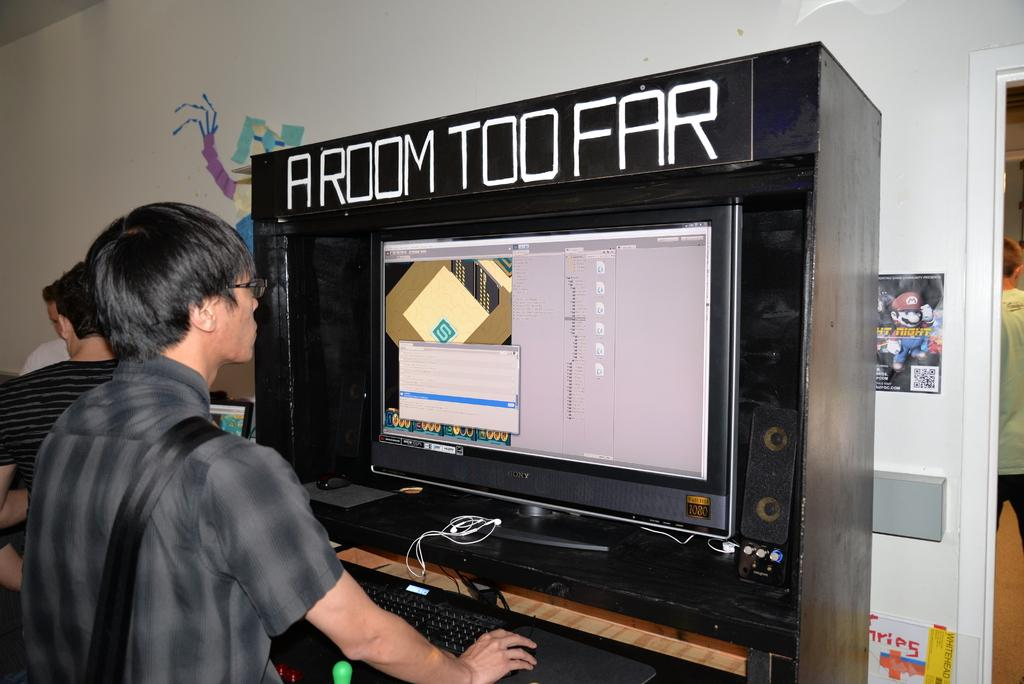<image>
Write a terse but informative summary of the picture. a person playing a game and a room too far written above 